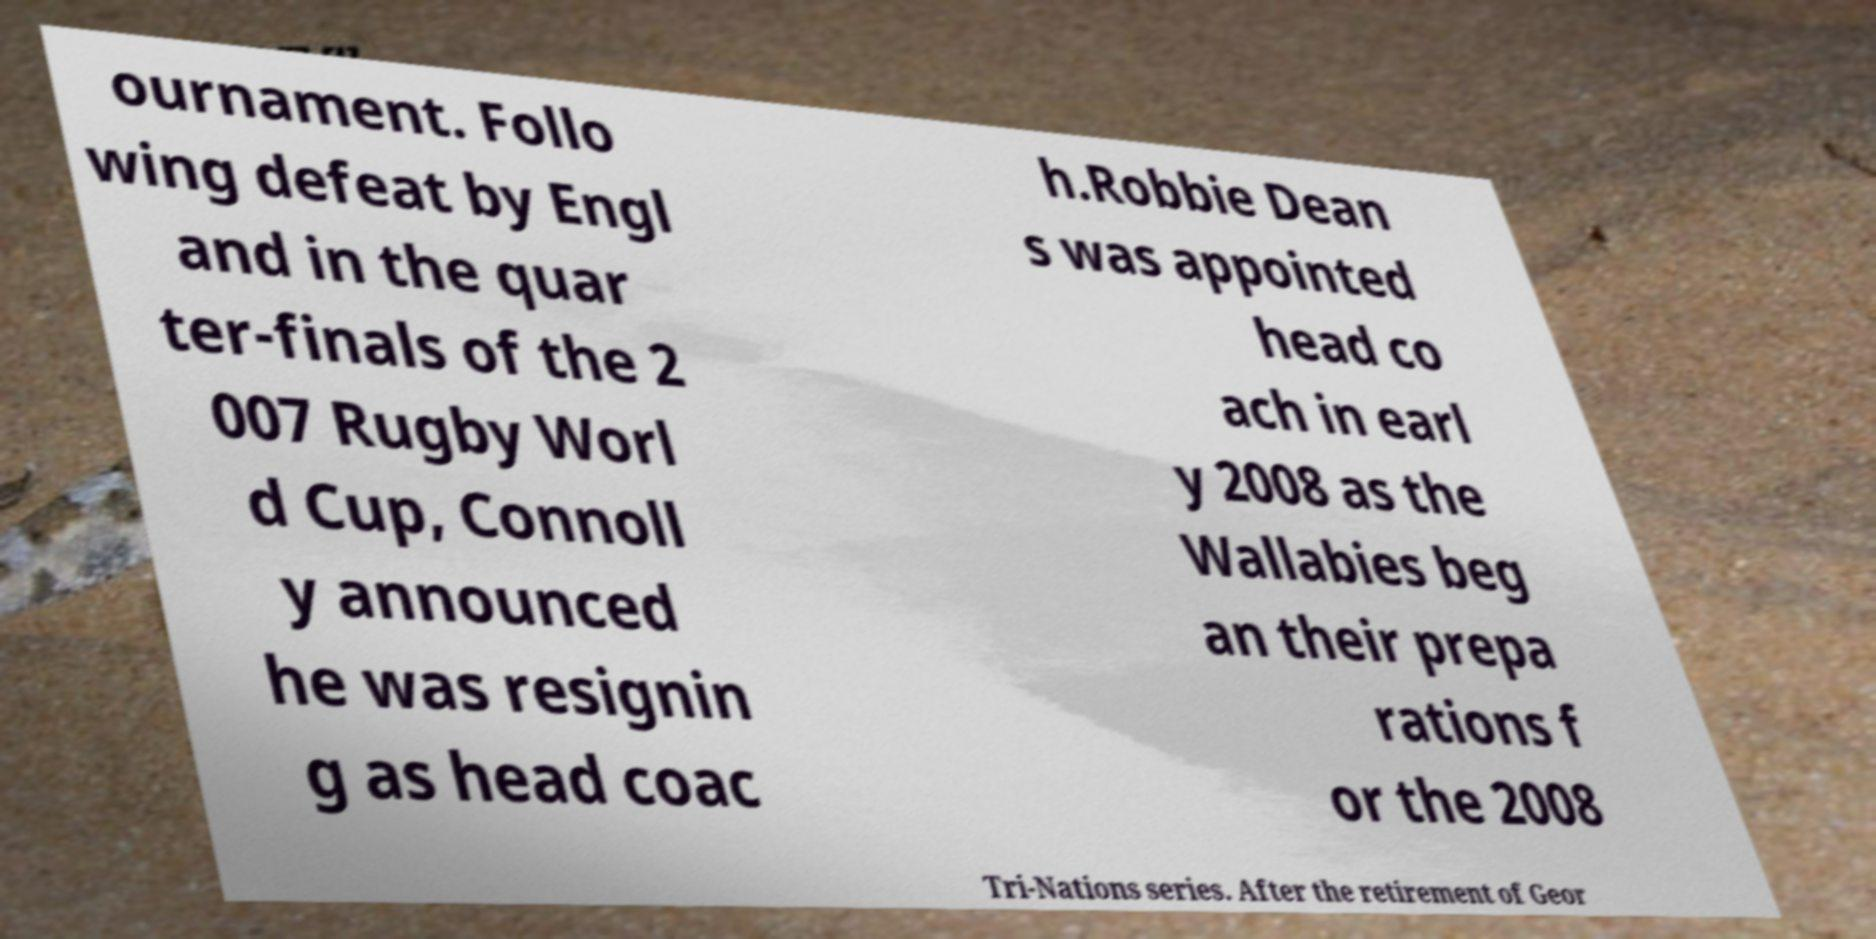Can you read and provide the text displayed in the image?This photo seems to have some interesting text. Can you extract and type it out for me? ournament. Follo wing defeat by Engl and in the quar ter-finals of the 2 007 Rugby Worl d Cup, Connoll y announced he was resignin g as head coac h.Robbie Dean s was appointed head co ach in earl y 2008 as the Wallabies beg an their prepa rations f or the 2008 Tri-Nations series. After the retirement of Geor 